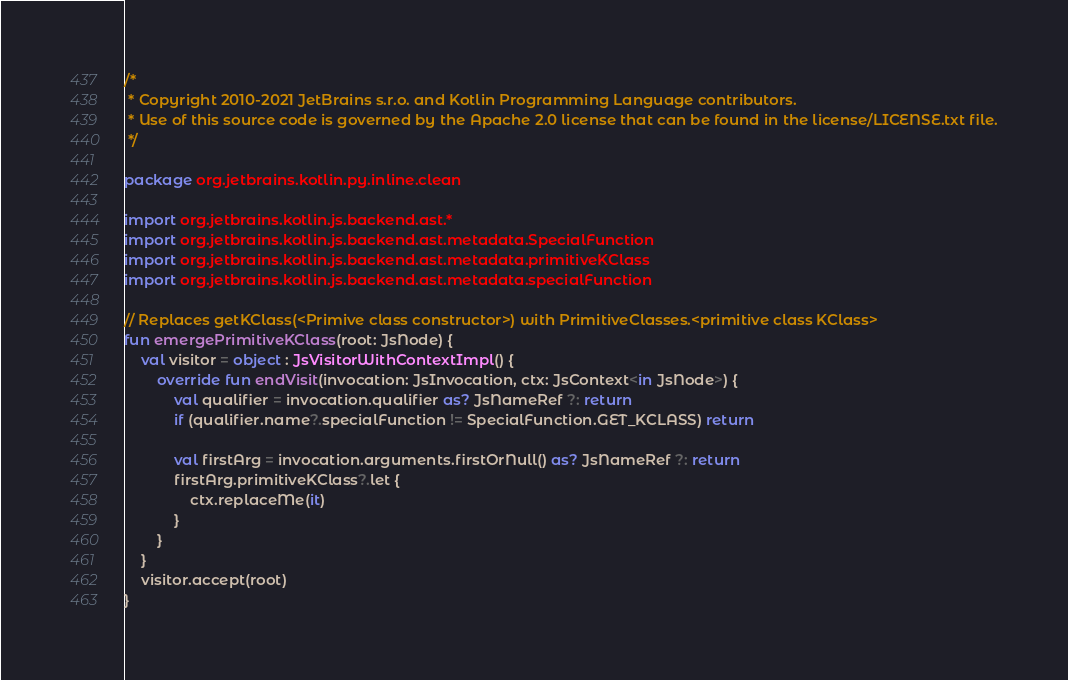Convert code to text. <code><loc_0><loc_0><loc_500><loc_500><_Kotlin_>/*
 * Copyright 2010-2021 JetBrains s.r.o. and Kotlin Programming Language contributors.
 * Use of this source code is governed by the Apache 2.0 license that can be found in the license/LICENSE.txt file.
 */

package org.jetbrains.kotlin.py.inline.clean

import org.jetbrains.kotlin.js.backend.ast.*
import org.jetbrains.kotlin.js.backend.ast.metadata.SpecialFunction
import org.jetbrains.kotlin.js.backend.ast.metadata.primitiveKClass
import org.jetbrains.kotlin.js.backend.ast.metadata.specialFunction

// Replaces getKClass(<Primive class constructor>) with PrimitiveClasses.<primitive class KClass>
fun emergePrimitiveKClass(root: JsNode) {
    val visitor = object : JsVisitorWithContextImpl() {
        override fun endVisit(invocation: JsInvocation, ctx: JsContext<in JsNode>) {
            val qualifier = invocation.qualifier as? JsNameRef ?: return
            if (qualifier.name?.specialFunction != SpecialFunction.GET_KCLASS) return

            val firstArg = invocation.arguments.firstOrNull() as? JsNameRef ?: return
            firstArg.primitiveKClass?.let {
                ctx.replaceMe(it)
            }
        }
    }
    visitor.accept(root)
}</code> 